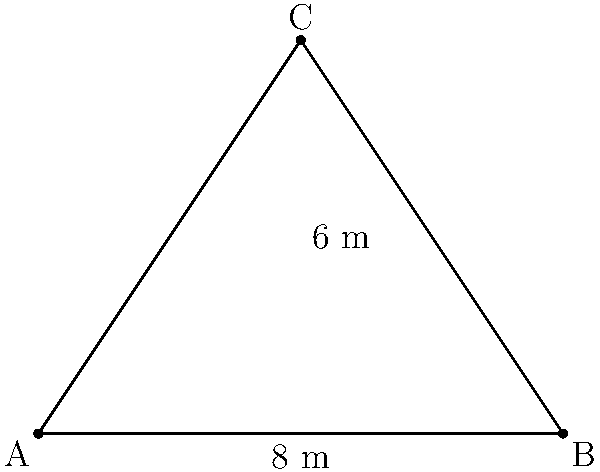In a historical naval battle from the 18th century, a ship's triangular sail is represented by the diagram above. If the base of the sail measures 8 meters and its height is 6 meters, what is the area of the sail in square meters? To find the area of the triangular sail, we can use the formula for the area of a triangle:

$$A = \frac{1}{2} \times base \times height$$

Given:
- Base of the triangle (sail) = 8 meters
- Height of the triangle (sail) = 6 meters

Let's substitute these values into the formula:

$$A = \frac{1}{2} \times 8 \times 6$$

Now, let's solve:

$$A = 4 \times 6 = 24$$

Therefore, the area of the triangular sail is 24 square meters.

This calculation would be crucial for a historical fiction writer to accurately describe the sail's size and its impact on the ship's performance during the naval battle.
Answer: 24 square meters 